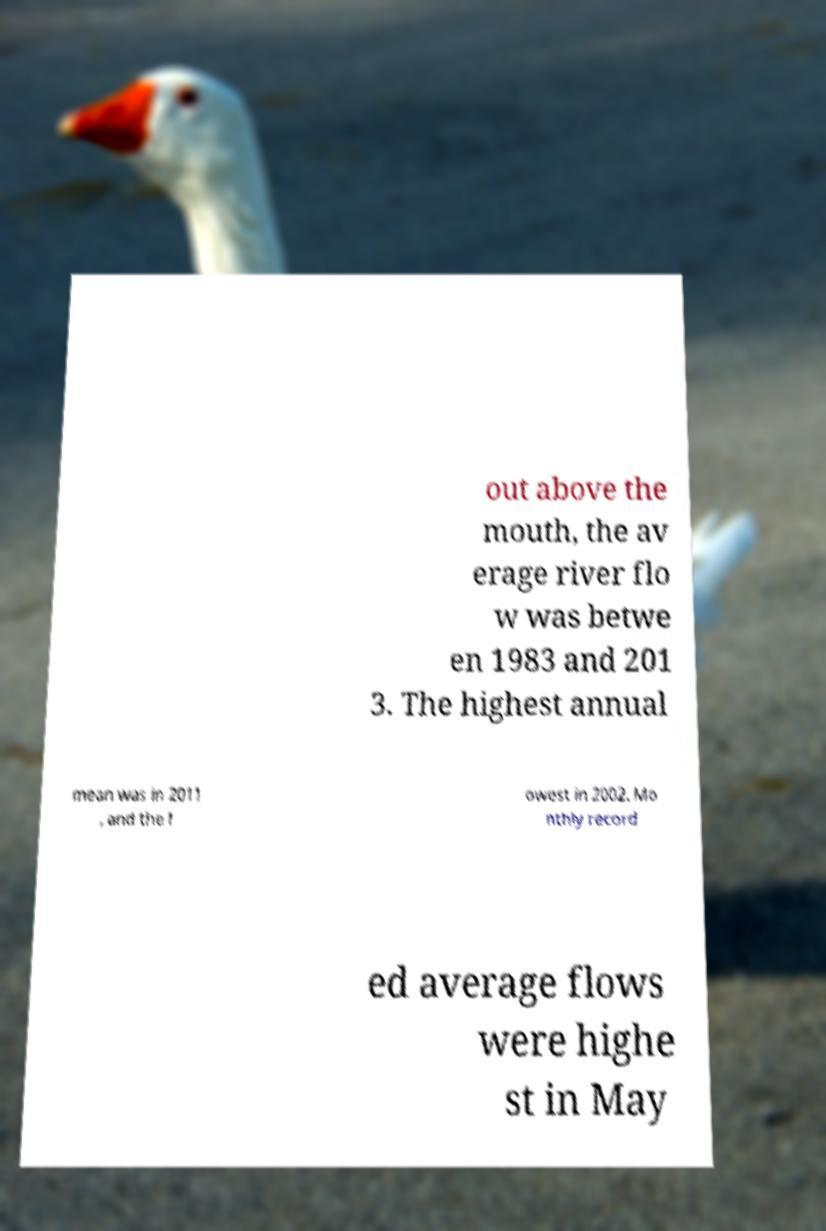There's text embedded in this image that I need extracted. Can you transcribe it verbatim? out above the mouth, the av erage river flo w was betwe en 1983 and 201 3. The highest annual mean was in 2011 , and the l owest in 2002. Mo nthly record ed average flows were highe st in May 